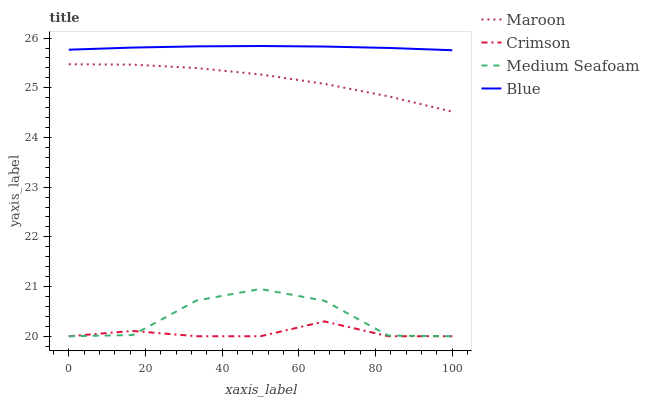Does Medium Seafoam have the minimum area under the curve?
Answer yes or no. No. Does Medium Seafoam have the maximum area under the curve?
Answer yes or no. No. Is Medium Seafoam the smoothest?
Answer yes or no. No. Is Blue the roughest?
Answer yes or no. No. Does Blue have the lowest value?
Answer yes or no. No. Does Medium Seafoam have the highest value?
Answer yes or no. No. Is Maroon less than Blue?
Answer yes or no. Yes. Is Blue greater than Maroon?
Answer yes or no. Yes. Does Maroon intersect Blue?
Answer yes or no. No. 